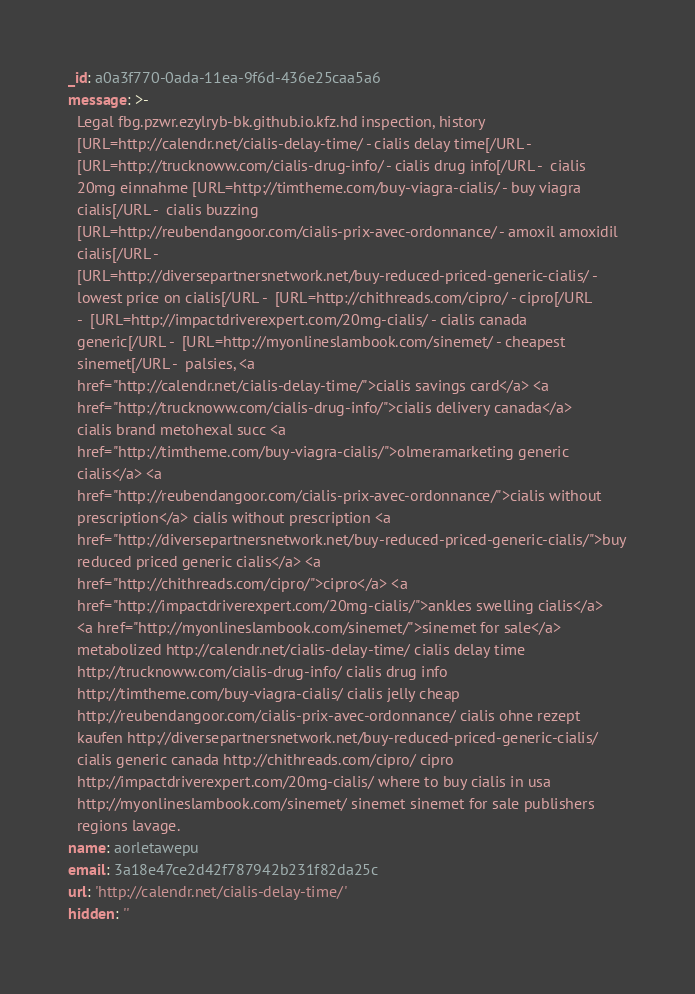Convert code to text. <code><loc_0><loc_0><loc_500><loc_500><_YAML_>_id: a0a3f770-0ada-11ea-9f6d-436e25caa5a6
message: >-
  Legal fbg.pzwr.ezylryb-bk.github.io.kfz.hd inspection, history
  [URL=http://calendr.net/cialis-delay-time/ - cialis delay time[/URL - 
  [URL=http://trucknoww.com/cialis-drug-info/ - cialis drug info[/URL -  cialis
  20mg einnahme [URL=http://timtheme.com/buy-viagra-cialis/ - buy viagra
  cialis[/URL -  cialis buzzing
  [URL=http://reubendangoor.com/cialis-prix-avec-ordonnance/ - amoxil amoxidil
  cialis[/URL - 
  [URL=http://diversepartnersnetwork.net/buy-reduced-priced-generic-cialis/ -
  lowest price on cialis[/URL -  [URL=http://chithreads.com/cipro/ - cipro[/URL
  -  [URL=http://impactdriverexpert.com/20mg-cialis/ - cialis canada
  generic[/URL -  [URL=http://myonlineslambook.com/sinemet/ - cheapest
  sinemet[/URL -  palsies, <a
  href="http://calendr.net/cialis-delay-time/">cialis savings card</a> <a
  href="http://trucknoww.com/cialis-drug-info/">cialis delivery canada</a>
  cialis brand metohexal succ <a
  href="http://timtheme.com/buy-viagra-cialis/">olmeramarketing generic
  cialis</a> <a
  href="http://reubendangoor.com/cialis-prix-avec-ordonnance/">cialis without
  prescription</a> cialis without prescription <a
  href="http://diversepartnersnetwork.net/buy-reduced-priced-generic-cialis/">buy
  reduced priced generic cialis</a> <a
  href="http://chithreads.com/cipro/">cipro</a> <a
  href="http://impactdriverexpert.com/20mg-cialis/">ankles swelling cialis</a>
  <a href="http://myonlineslambook.com/sinemet/">sinemet for sale</a>
  metabolized http://calendr.net/cialis-delay-time/ cialis delay time
  http://trucknoww.com/cialis-drug-info/ cialis drug info
  http://timtheme.com/buy-viagra-cialis/ cialis jelly cheap
  http://reubendangoor.com/cialis-prix-avec-ordonnance/ cialis ohne rezept
  kaufen http://diversepartnersnetwork.net/buy-reduced-priced-generic-cialis/
  cialis generic canada http://chithreads.com/cipro/ cipro
  http://impactdriverexpert.com/20mg-cialis/ where to buy cialis in usa
  http://myonlineslambook.com/sinemet/ sinemet sinemet for sale publishers
  regions lavage.
name: aorletawepu
email: 3a18e47ce2d42f787942b231f82da25c
url: 'http://calendr.net/cialis-delay-time/'
hidden: ''</code> 